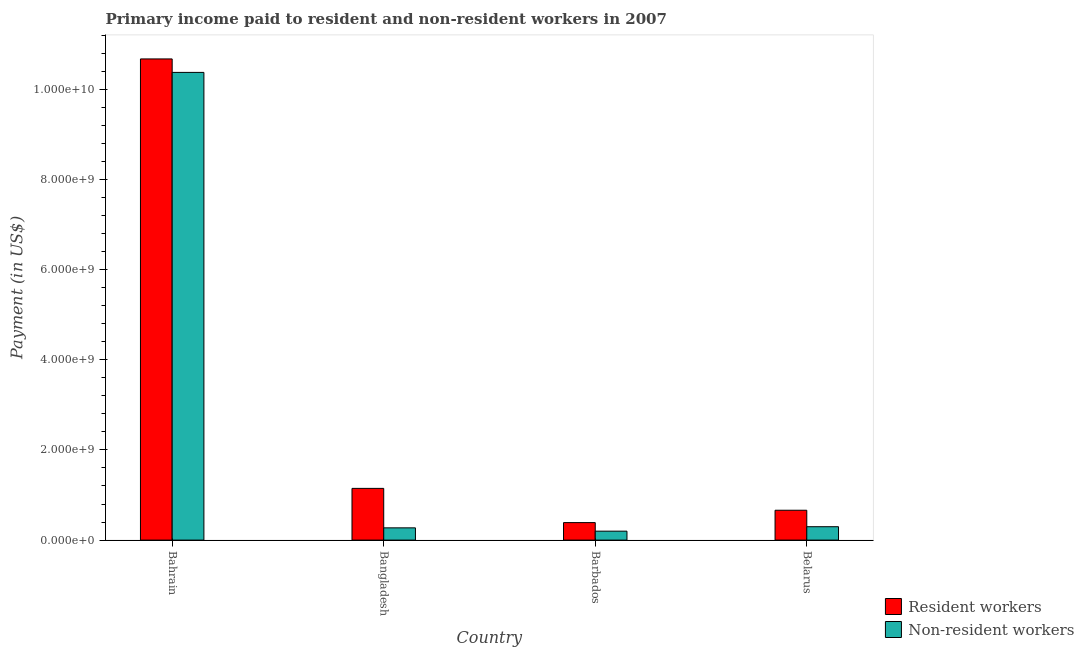How many groups of bars are there?
Keep it short and to the point. 4. Are the number of bars per tick equal to the number of legend labels?
Make the answer very short. Yes. How many bars are there on the 4th tick from the right?
Provide a short and direct response. 2. What is the label of the 3rd group of bars from the left?
Your answer should be very brief. Barbados. What is the payment made to non-resident workers in Barbados?
Make the answer very short. 1.98e+08. Across all countries, what is the maximum payment made to resident workers?
Ensure brevity in your answer.  1.07e+1. Across all countries, what is the minimum payment made to resident workers?
Provide a short and direct response. 3.88e+08. In which country was the payment made to resident workers maximum?
Offer a terse response. Bahrain. In which country was the payment made to non-resident workers minimum?
Ensure brevity in your answer.  Barbados. What is the total payment made to non-resident workers in the graph?
Provide a succinct answer. 1.11e+1. What is the difference between the payment made to non-resident workers in Barbados and that in Belarus?
Offer a very short reply. -9.89e+07. What is the difference between the payment made to resident workers in Bangladesh and the payment made to non-resident workers in Belarus?
Make the answer very short. 8.50e+08. What is the average payment made to resident workers per country?
Provide a succinct answer. 3.22e+09. What is the difference between the payment made to non-resident workers and payment made to resident workers in Barbados?
Give a very brief answer. -1.90e+08. What is the ratio of the payment made to resident workers in Bahrain to that in Barbados?
Provide a short and direct response. 27.51. What is the difference between the highest and the second highest payment made to non-resident workers?
Make the answer very short. 1.01e+1. What is the difference between the highest and the lowest payment made to resident workers?
Provide a short and direct response. 1.03e+1. What does the 1st bar from the left in Barbados represents?
Offer a terse response. Resident workers. What does the 1st bar from the right in Bangladesh represents?
Make the answer very short. Non-resident workers. How many bars are there?
Give a very brief answer. 8. Are all the bars in the graph horizontal?
Your answer should be compact. No. Are the values on the major ticks of Y-axis written in scientific E-notation?
Provide a succinct answer. Yes. Does the graph contain grids?
Ensure brevity in your answer.  No. How are the legend labels stacked?
Offer a very short reply. Vertical. What is the title of the graph?
Your answer should be very brief. Primary income paid to resident and non-resident workers in 2007. What is the label or title of the X-axis?
Keep it short and to the point. Country. What is the label or title of the Y-axis?
Provide a short and direct response. Payment (in US$). What is the Payment (in US$) in Resident workers in Bahrain?
Ensure brevity in your answer.  1.07e+1. What is the Payment (in US$) of Non-resident workers in Bahrain?
Give a very brief answer. 1.04e+1. What is the Payment (in US$) of Resident workers in Bangladesh?
Your response must be concise. 1.15e+09. What is the Payment (in US$) of Non-resident workers in Bangladesh?
Keep it short and to the point. 2.72e+08. What is the Payment (in US$) in Resident workers in Barbados?
Your answer should be very brief. 3.88e+08. What is the Payment (in US$) in Non-resident workers in Barbados?
Offer a terse response. 1.98e+08. What is the Payment (in US$) in Resident workers in Belarus?
Provide a succinct answer. 6.62e+08. What is the Payment (in US$) of Non-resident workers in Belarus?
Ensure brevity in your answer.  2.97e+08. Across all countries, what is the maximum Payment (in US$) of Resident workers?
Your answer should be compact. 1.07e+1. Across all countries, what is the maximum Payment (in US$) of Non-resident workers?
Provide a succinct answer. 1.04e+1. Across all countries, what is the minimum Payment (in US$) of Resident workers?
Provide a short and direct response. 3.88e+08. Across all countries, what is the minimum Payment (in US$) of Non-resident workers?
Your answer should be compact. 1.98e+08. What is the total Payment (in US$) in Resident workers in the graph?
Offer a very short reply. 1.29e+1. What is the total Payment (in US$) in Non-resident workers in the graph?
Offer a very short reply. 1.11e+1. What is the difference between the Payment (in US$) in Resident workers in Bahrain and that in Bangladesh?
Keep it short and to the point. 9.53e+09. What is the difference between the Payment (in US$) of Non-resident workers in Bahrain and that in Bangladesh?
Your answer should be very brief. 1.01e+1. What is the difference between the Payment (in US$) in Resident workers in Bahrain and that in Barbados?
Provide a succinct answer. 1.03e+1. What is the difference between the Payment (in US$) of Non-resident workers in Bahrain and that in Barbados?
Your answer should be compact. 1.02e+1. What is the difference between the Payment (in US$) of Resident workers in Bahrain and that in Belarus?
Provide a short and direct response. 1.00e+1. What is the difference between the Payment (in US$) in Non-resident workers in Bahrain and that in Belarus?
Provide a succinct answer. 1.01e+1. What is the difference between the Payment (in US$) of Resident workers in Bangladesh and that in Barbados?
Make the answer very short. 7.59e+08. What is the difference between the Payment (in US$) of Non-resident workers in Bangladesh and that in Barbados?
Ensure brevity in your answer.  7.34e+07. What is the difference between the Payment (in US$) of Resident workers in Bangladesh and that in Belarus?
Your answer should be very brief. 4.85e+08. What is the difference between the Payment (in US$) in Non-resident workers in Bangladesh and that in Belarus?
Ensure brevity in your answer.  -2.54e+07. What is the difference between the Payment (in US$) of Resident workers in Barbados and that in Belarus?
Provide a short and direct response. -2.74e+08. What is the difference between the Payment (in US$) in Non-resident workers in Barbados and that in Belarus?
Make the answer very short. -9.89e+07. What is the difference between the Payment (in US$) in Resident workers in Bahrain and the Payment (in US$) in Non-resident workers in Bangladesh?
Your answer should be very brief. 1.04e+1. What is the difference between the Payment (in US$) in Resident workers in Bahrain and the Payment (in US$) in Non-resident workers in Barbados?
Offer a terse response. 1.05e+1. What is the difference between the Payment (in US$) of Resident workers in Bahrain and the Payment (in US$) of Non-resident workers in Belarus?
Offer a very short reply. 1.04e+1. What is the difference between the Payment (in US$) in Resident workers in Bangladesh and the Payment (in US$) in Non-resident workers in Barbados?
Your answer should be very brief. 9.49e+08. What is the difference between the Payment (in US$) in Resident workers in Bangladesh and the Payment (in US$) in Non-resident workers in Belarus?
Keep it short and to the point. 8.50e+08. What is the difference between the Payment (in US$) in Resident workers in Barbados and the Payment (in US$) in Non-resident workers in Belarus?
Provide a short and direct response. 9.09e+07. What is the average Payment (in US$) in Resident workers per country?
Give a very brief answer. 3.22e+09. What is the average Payment (in US$) in Non-resident workers per country?
Provide a succinct answer. 2.79e+09. What is the difference between the Payment (in US$) in Resident workers and Payment (in US$) in Non-resident workers in Bahrain?
Your response must be concise. 2.99e+08. What is the difference between the Payment (in US$) of Resident workers and Payment (in US$) of Non-resident workers in Bangladesh?
Ensure brevity in your answer.  8.75e+08. What is the difference between the Payment (in US$) in Resident workers and Payment (in US$) in Non-resident workers in Barbados?
Your response must be concise. 1.90e+08. What is the difference between the Payment (in US$) in Resident workers and Payment (in US$) in Non-resident workers in Belarus?
Offer a very short reply. 3.65e+08. What is the ratio of the Payment (in US$) of Resident workers in Bahrain to that in Bangladesh?
Your answer should be very brief. 9.3. What is the ratio of the Payment (in US$) in Non-resident workers in Bahrain to that in Bangladesh?
Offer a terse response. 38.18. What is the ratio of the Payment (in US$) in Resident workers in Bahrain to that in Barbados?
Keep it short and to the point. 27.51. What is the ratio of the Payment (in US$) in Non-resident workers in Bahrain to that in Barbados?
Offer a terse response. 52.33. What is the ratio of the Payment (in US$) of Resident workers in Bahrain to that in Belarus?
Give a very brief answer. 16.12. What is the ratio of the Payment (in US$) of Non-resident workers in Bahrain to that in Belarus?
Your answer should be compact. 34.92. What is the ratio of the Payment (in US$) of Resident workers in Bangladesh to that in Barbados?
Ensure brevity in your answer.  2.96. What is the ratio of the Payment (in US$) of Non-resident workers in Bangladesh to that in Barbados?
Your answer should be compact. 1.37. What is the ratio of the Payment (in US$) in Resident workers in Bangladesh to that in Belarus?
Make the answer very short. 1.73. What is the ratio of the Payment (in US$) in Non-resident workers in Bangladesh to that in Belarus?
Make the answer very short. 0.91. What is the ratio of the Payment (in US$) in Resident workers in Barbados to that in Belarus?
Provide a short and direct response. 0.59. What is the ratio of the Payment (in US$) of Non-resident workers in Barbados to that in Belarus?
Provide a short and direct response. 0.67. What is the difference between the highest and the second highest Payment (in US$) of Resident workers?
Make the answer very short. 9.53e+09. What is the difference between the highest and the second highest Payment (in US$) in Non-resident workers?
Keep it short and to the point. 1.01e+1. What is the difference between the highest and the lowest Payment (in US$) of Resident workers?
Your answer should be very brief. 1.03e+1. What is the difference between the highest and the lowest Payment (in US$) in Non-resident workers?
Your answer should be compact. 1.02e+1. 